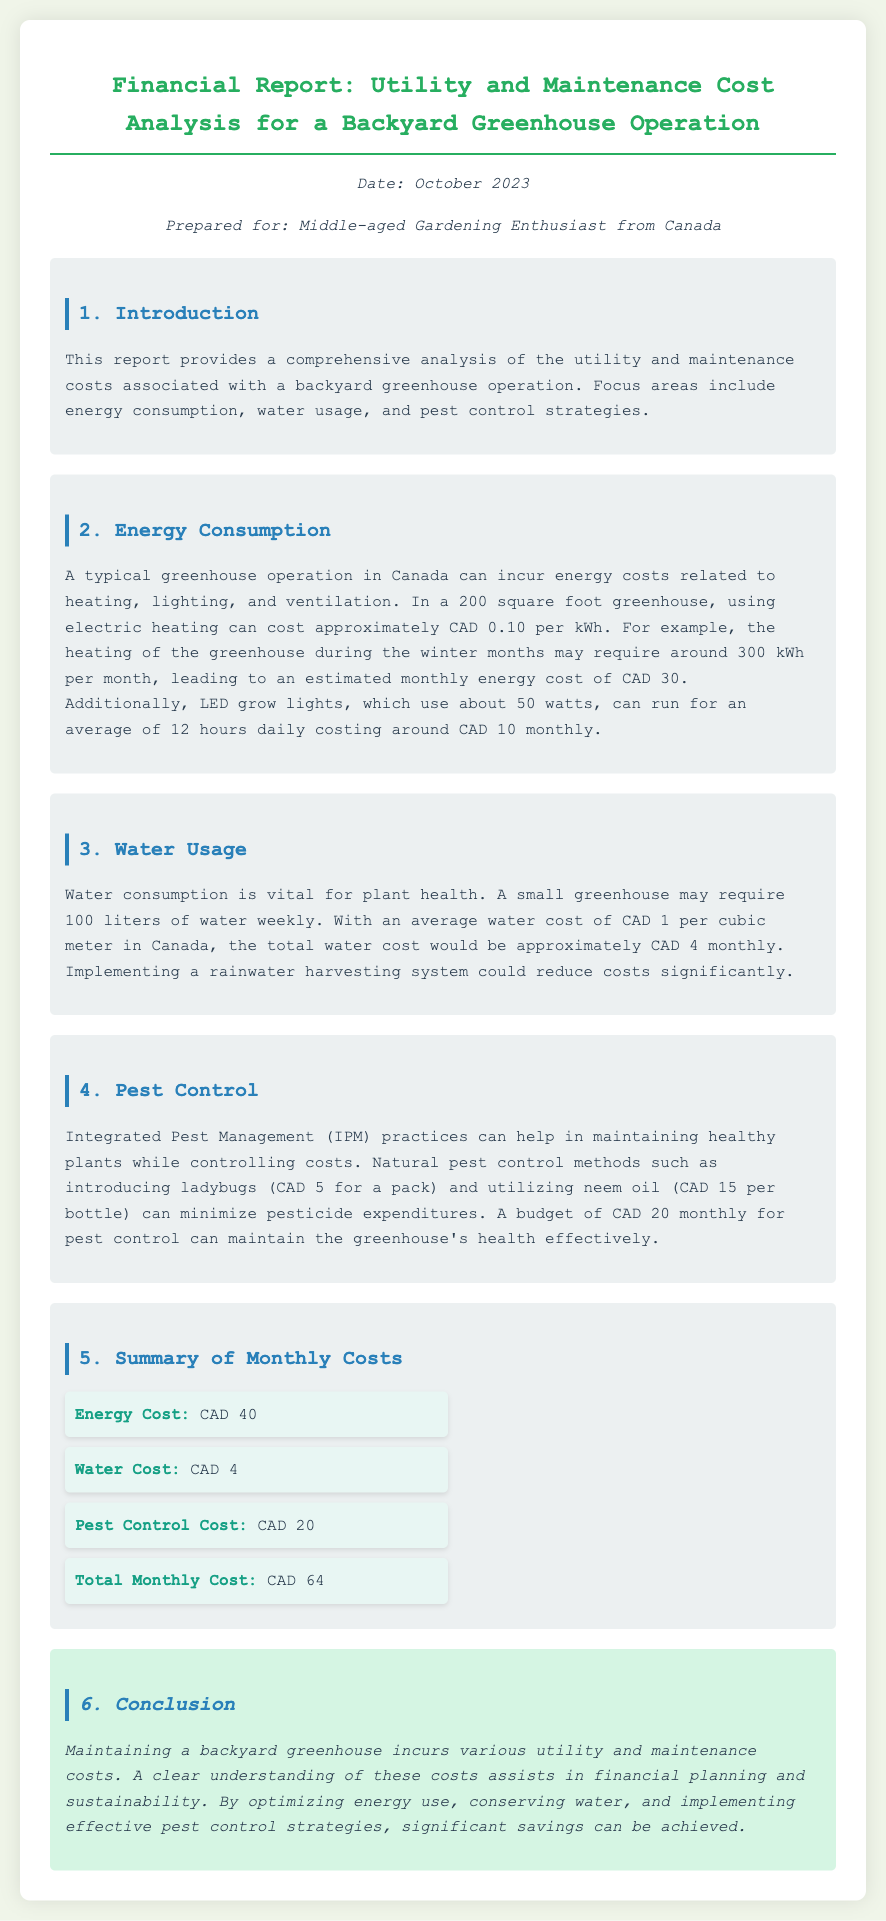What is the date of the report? The date of the report is mentioned in the meta-info section of the document.
Answer: October 2023 What is the cost of electricity used for heating monthly? The monthly energy cost for heating in the greenhouse operation is detailed in the energy consumption section.
Answer: CAD 30 How much does water cost monthly? The water cost is provided in the water usage section of the document.
Answer: CAD 4 What is included in the total monthly cost? The total monthly cost is the sum of energy, water, and pest control costs provided in the summary section.
Answer: CAD 64 What is the estimated budget for pest control? The document specifies the budget allocation for pest control in the pest control section.
Answer: CAD 20 What alternative system could reduce water costs? The report discusses alternatives to traditional water usage in the water usage section.
Answer: Rainwater harvesting system How much power do the LED grow lights consume? The energy consumption of LED grow lights is specified in the energy consumption section of the report.
Answer: 50 watts What is the total energy cost, combining heating and lighting? The total energy cost calculated from the energy section includes both heating and lighting costs.
Answer: CAD 40 